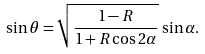Convert formula to latex. <formula><loc_0><loc_0><loc_500><loc_500>\sin \theta = \sqrt { \frac { 1 - R } { 1 + R \cos 2 \alpha } } \, \sin \alpha .</formula> 